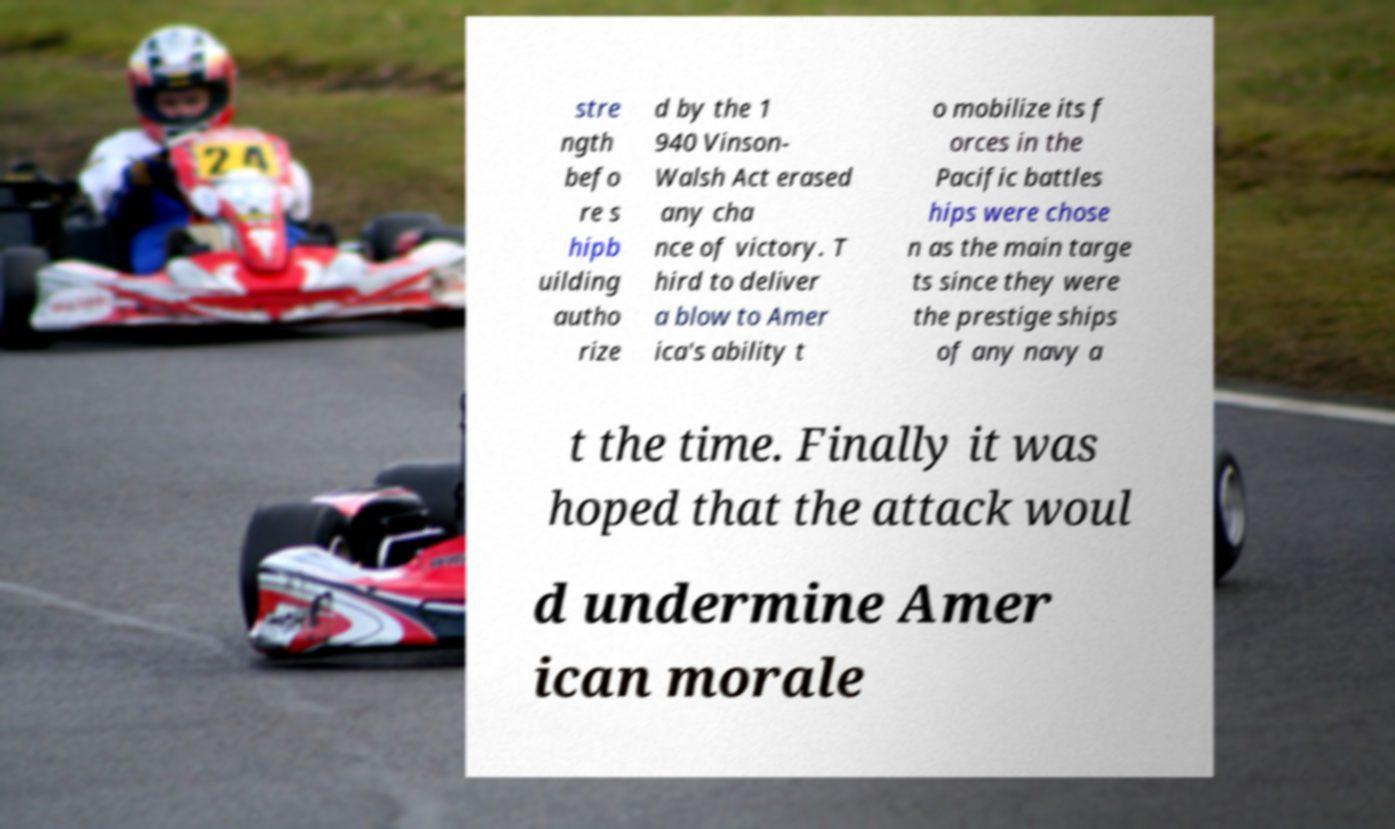There's text embedded in this image that I need extracted. Can you transcribe it verbatim? stre ngth befo re s hipb uilding autho rize d by the 1 940 Vinson- Walsh Act erased any cha nce of victory. T hird to deliver a blow to Amer ica's ability t o mobilize its f orces in the Pacific battles hips were chose n as the main targe ts since they were the prestige ships of any navy a t the time. Finally it was hoped that the attack woul d undermine Amer ican morale 